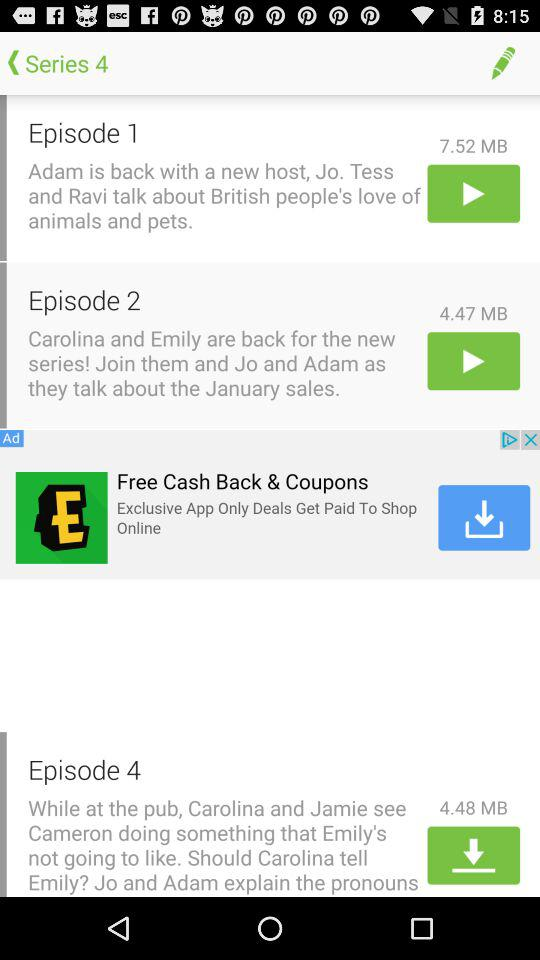How many episodes are in series 4?
Answer the question using a single word or phrase. 4 